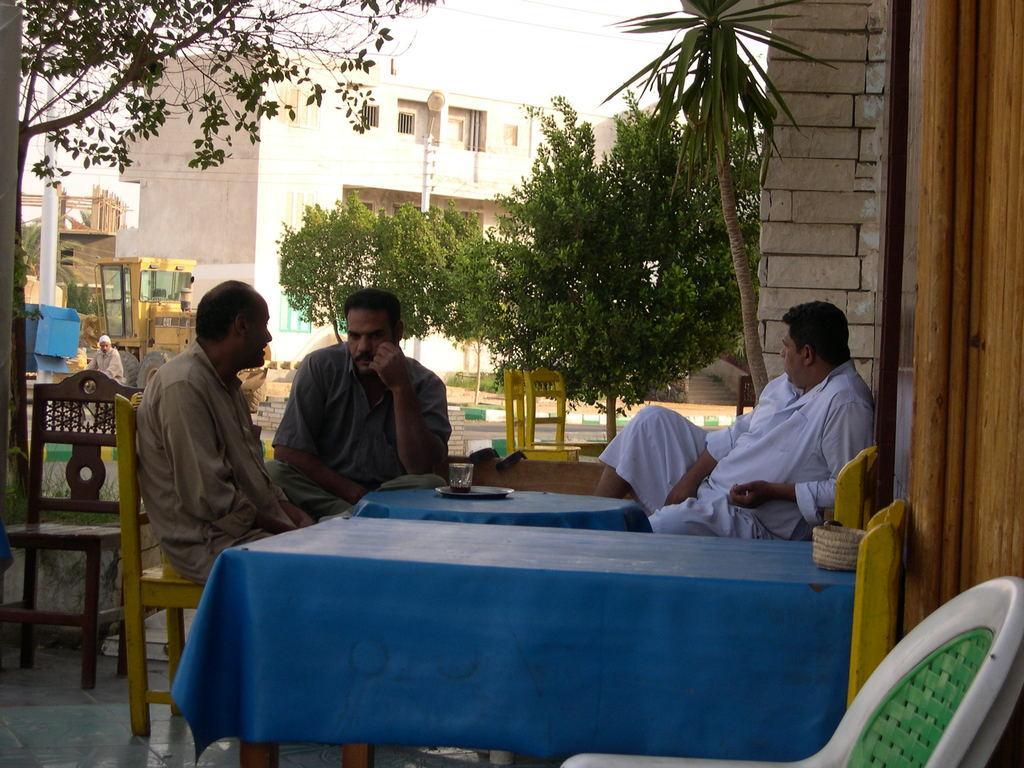Could you give a brief overview of what you see in this image? In this there are three men sitting on a chair. In front of them there is a table with blue color cloth on it. On the table there is a plate with the glass. And in the background there are some trees. And to the right side there is a crane and a white color pole. 